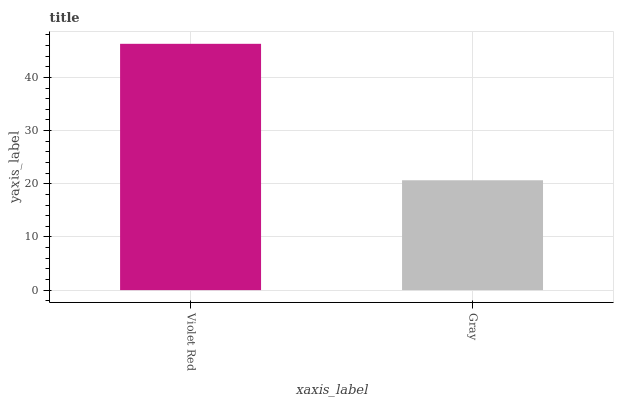Is Gray the minimum?
Answer yes or no. Yes. Is Violet Red the maximum?
Answer yes or no. Yes. Is Gray the maximum?
Answer yes or no. No. Is Violet Red greater than Gray?
Answer yes or no. Yes. Is Gray less than Violet Red?
Answer yes or no. Yes. Is Gray greater than Violet Red?
Answer yes or no. No. Is Violet Red less than Gray?
Answer yes or no. No. Is Violet Red the high median?
Answer yes or no. Yes. Is Gray the low median?
Answer yes or no. Yes. Is Gray the high median?
Answer yes or no. No. Is Violet Red the low median?
Answer yes or no. No. 